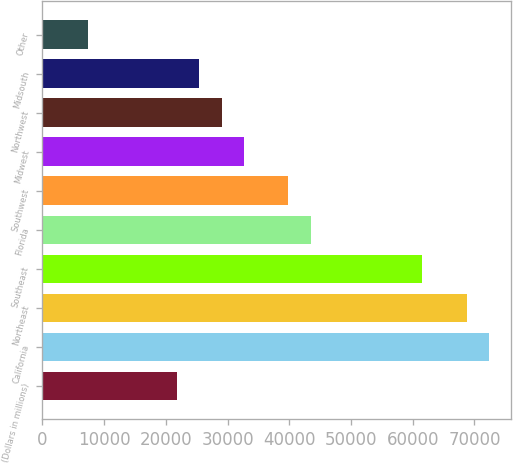Convert chart. <chart><loc_0><loc_0><loc_500><loc_500><bar_chart><fcel>(Dollars in millions)<fcel>California<fcel>Northeast<fcel>Southeast<fcel>Florida<fcel>Southwest<fcel>Midwest<fcel>Northwest<fcel>Midsouth<fcel>Other<nl><fcel>21826.8<fcel>72336<fcel>68728.2<fcel>61512.6<fcel>43473.6<fcel>39865.8<fcel>32650.2<fcel>29042.4<fcel>25434.6<fcel>7395.6<nl></chart> 